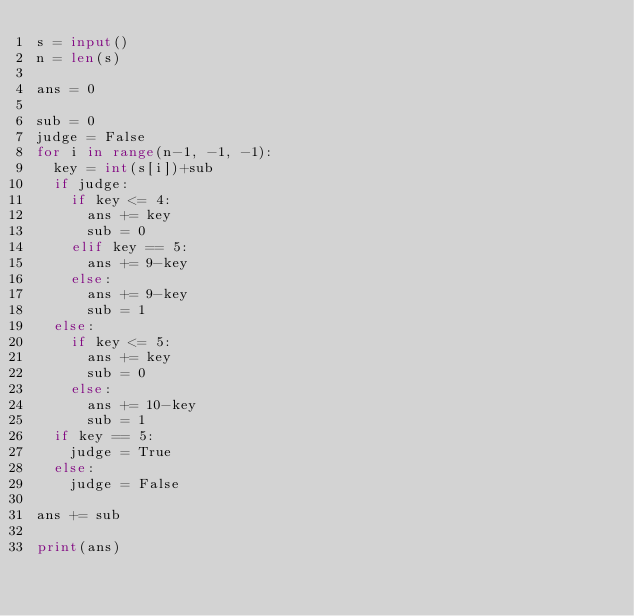<code> <loc_0><loc_0><loc_500><loc_500><_Python_>s = input()
n = len(s)

ans = 0

sub = 0
judge = False
for i in range(n-1, -1, -1):
  key = int(s[i])+sub
  if judge:
    if key <= 4:
      ans += key
      sub = 0
    elif key == 5:
      ans += 9-key
    else:
      ans += 9-key
      sub = 1
  else:
    if key <= 5:
      ans += key
      sub = 0
    else:
      ans += 10-key
      sub = 1
  if key == 5:
    judge = True
  else:
    judge = False

ans += sub

print(ans)</code> 